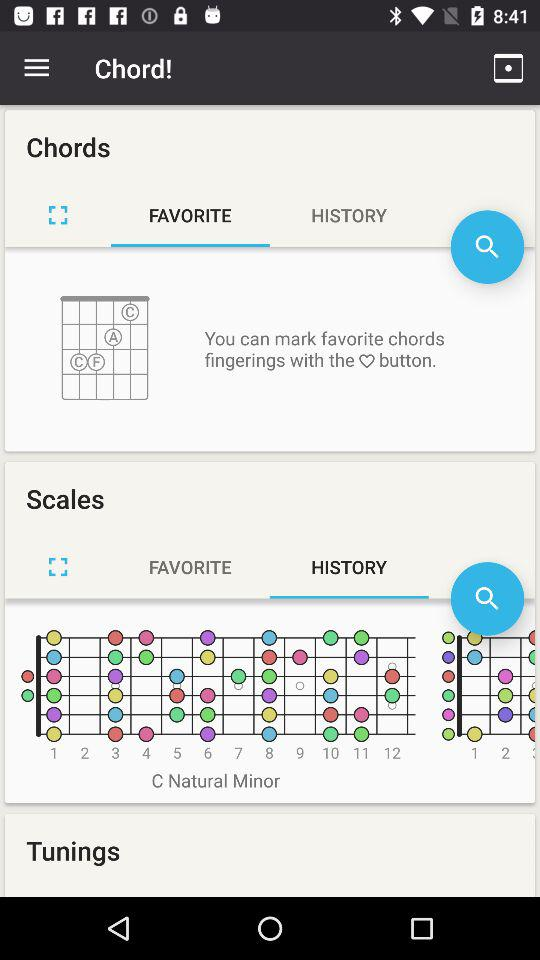Which tab is selected in "Scales"? The selected tab in "Scales" is "HISTORY". 